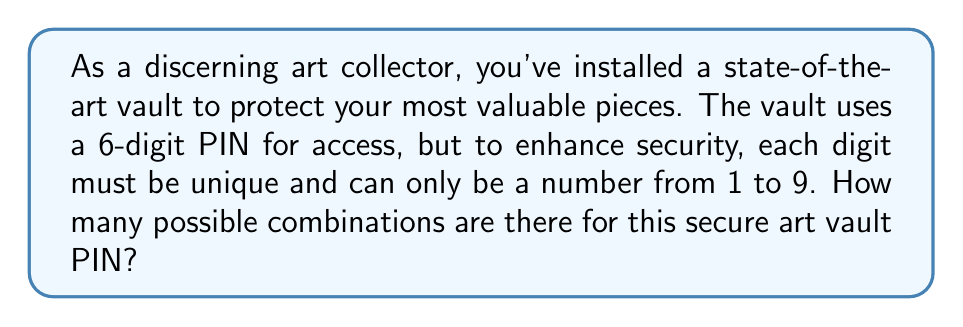Help me with this question. Let's approach this step-by-step:

1) We need to select 6 digits from the numbers 1 to 9, where each digit can only be used once. This is a permutation problem.

2) For the first digit, we have 9 choices (any number from 1 to 9).

3) For the second digit, we have 8 choices (any of the remaining numbers).

4) For the third digit, we have 7 choices, and so on.

5) This continues until we choose the sixth and final digit, where we have 4 choices.

6) The total number of combinations is the product of these choices:

   $$9 \times 8 \times 7 \times 6 \times 5 \times 4$$

7) This is equivalent to the permutation formula:

   $$P(9,6) = \frac{9!}{(9-6)!} = \frac{9!}{3!}$$

8) Calculating this:
   
   $$\frac{9 \times 8 \times 7 \times 6 \times 5 \times 4 \times 3!}{3!} = 9 \times 8 \times 7 \times 6 \times 5 \times 4 = 60,480$$

Therefore, there are 60,480 possible combinations for the secure art vault PIN.
Answer: 60,480 